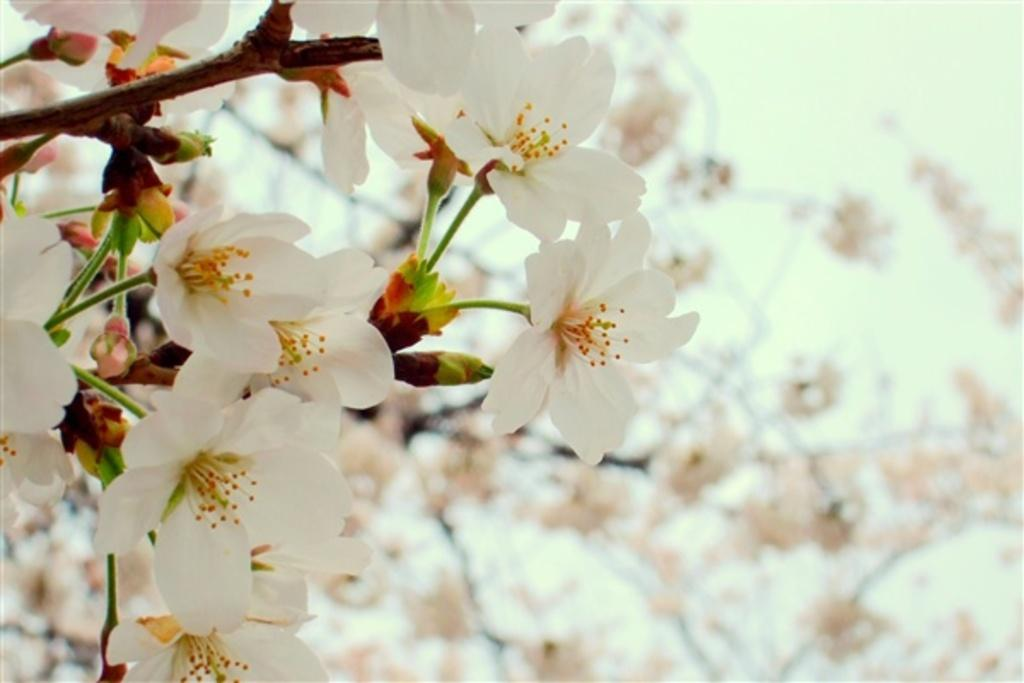What type of plants can be seen in the image? There are flowers in the image. Can you describe the background of the image? The background of the image is blurred. What type of sticks can be seen blowing in the wind in the image? There are no sticks or wind present in the image; it features flowers with a blurred background. 